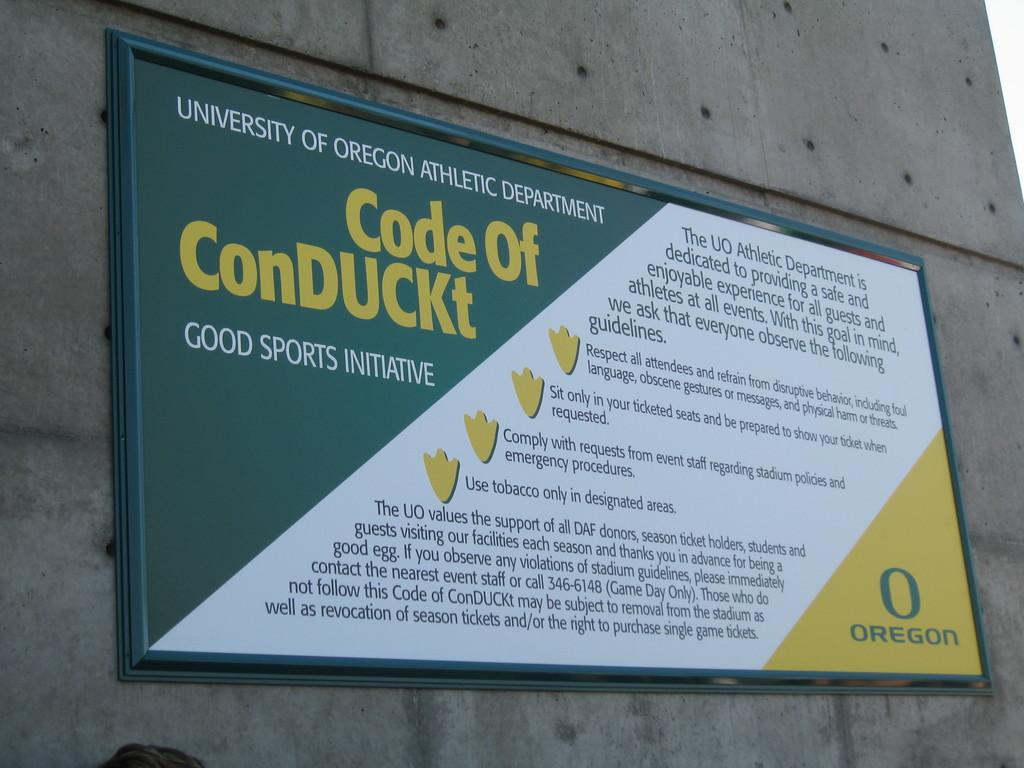What state is on this sign?
Your response must be concise. Oregon. What university is this sign for?
Make the answer very short. University of oregon. 